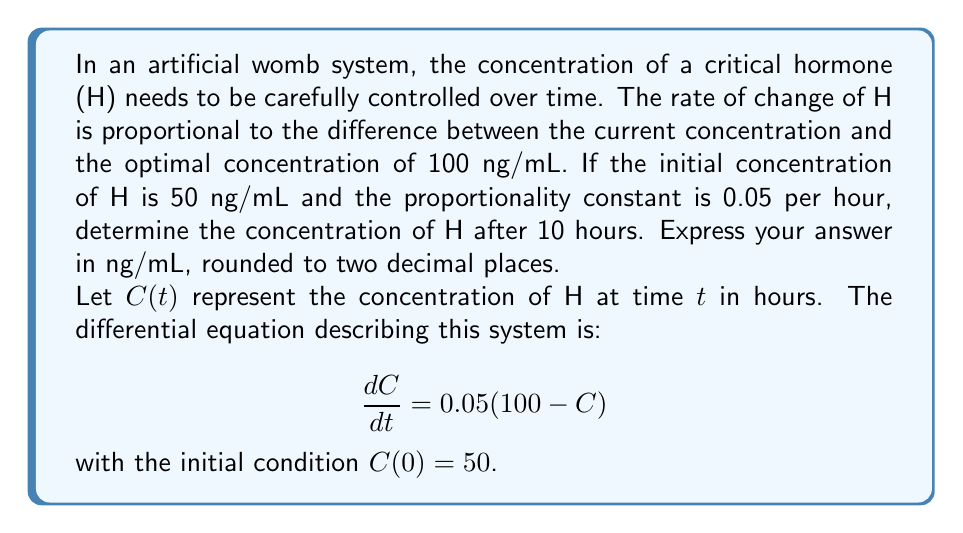Could you help me with this problem? To solve this first-order differential equation:

1) Rearrange the equation:
   $$\frac{dC}{dt} = 5 - 0.05C$$

2) This is a linear first-order differential equation of the form:
   $$\frac{dC}{dt} + 0.05C = 5$$

3) The integrating factor is $e^{\int 0.05 dt} = e^{0.05t}$

4) Multiply both sides by the integrating factor:
   $$e^{0.05t}\frac{dC}{dt} + 0.05e^{0.05t}C = 5e^{0.05t}$$

5) The left side is now the derivative of $e^{0.05t}C$:
   $$\frac{d}{dt}(e^{0.05t}C) = 5e^{0.05t}$$

6) Integrate both sides:
   $$e^{0.05t}C = 100e^{0.05t} + K$$

7) Solve for C:
   $$C = 100 + Ke^{-0.05t}$$

8) Use the initial condition $C(0) = 50$ to find K:
   $$50 = 100 + K$$
   $$K = -50$$

9) The final solution is:
   $$C(t) = 100 - 50e^{-0.05t}$$

10) To find C(10), substitute t = 10:
    $$C(10) = 100 - 50e^{-0.05(10)} = 100 - 50e^{-0.5} \approx 69.32$$
Answer: 69.32 ng/mL 